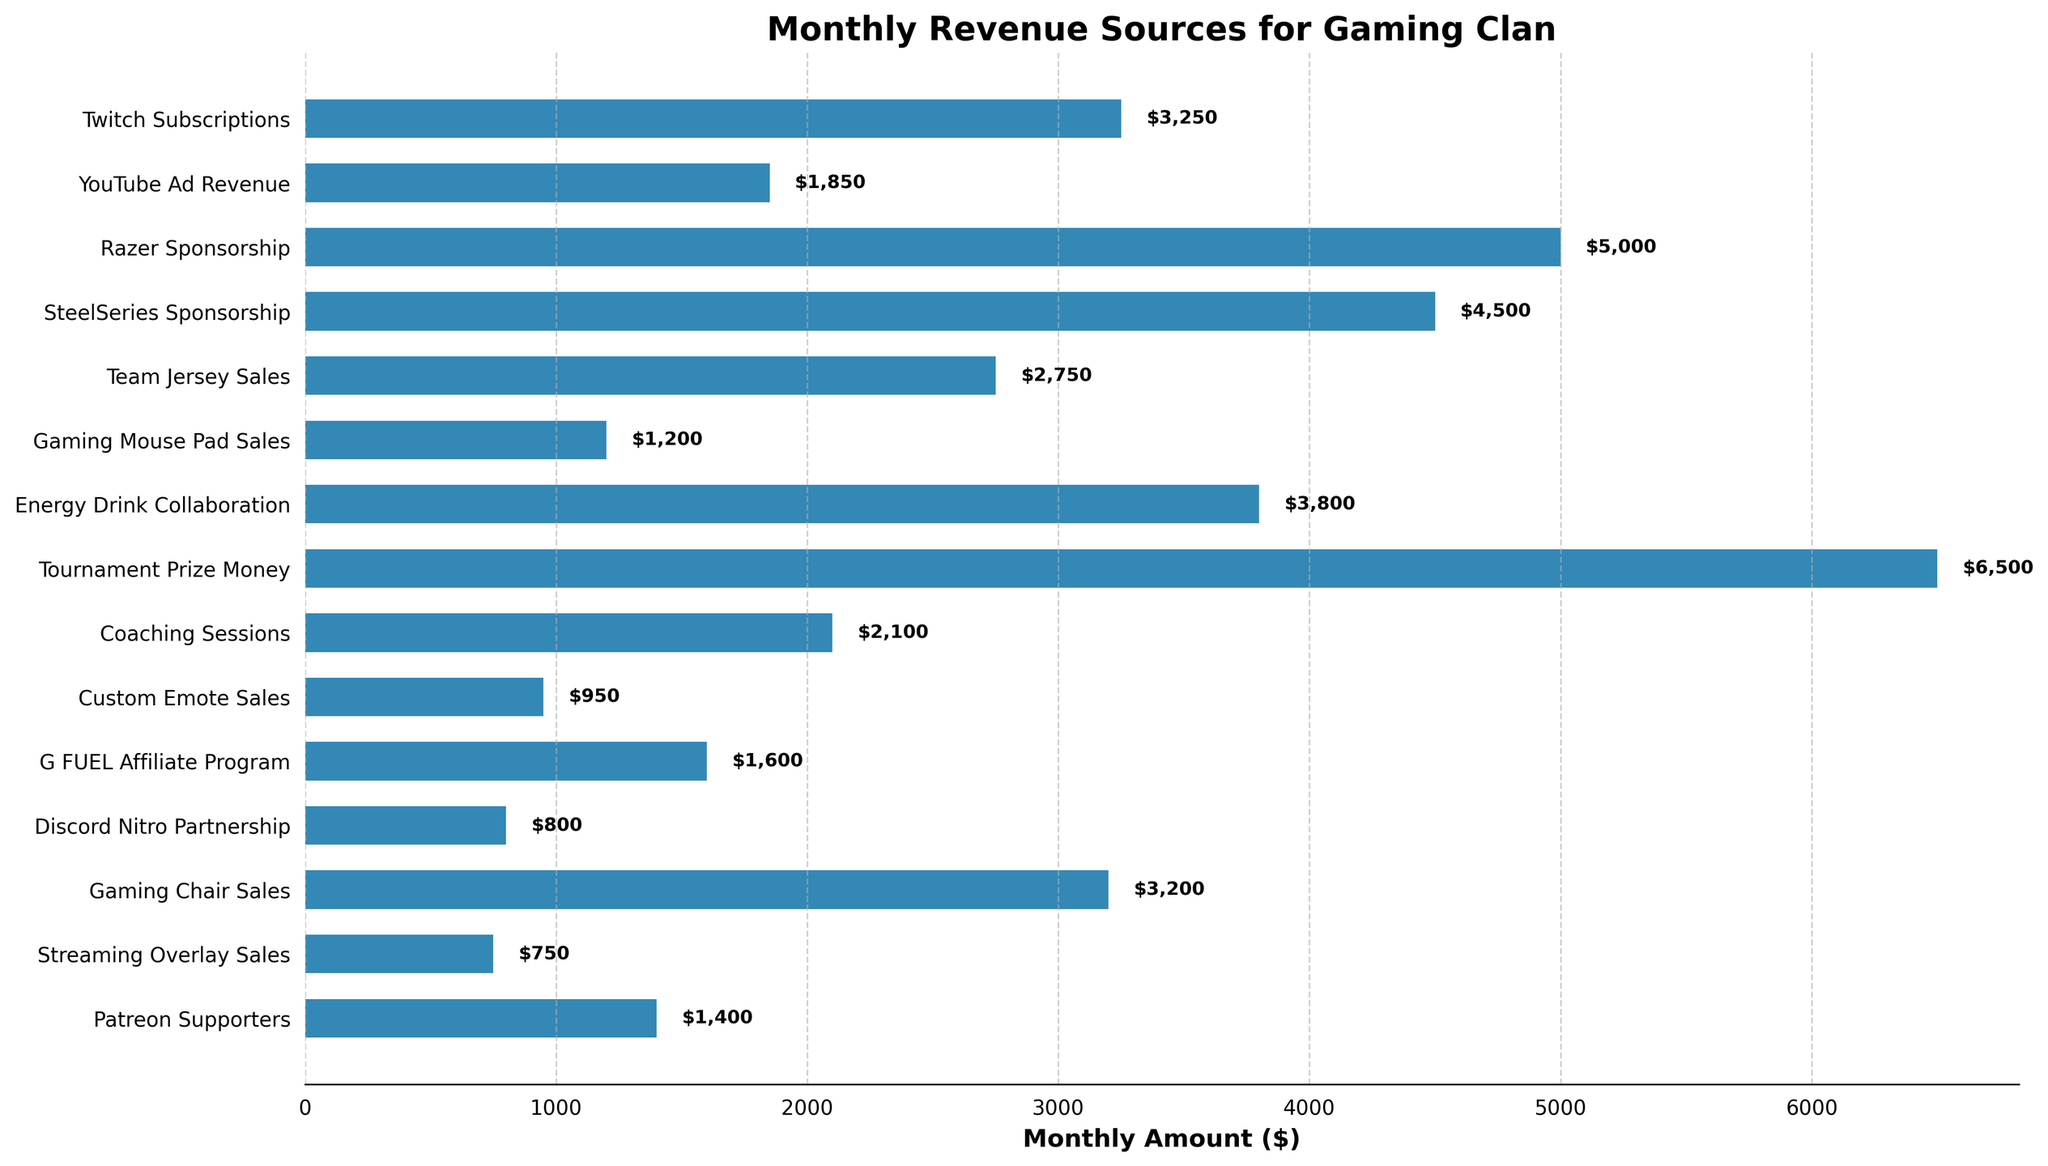What's the total monthly revenue from all sources combined? Sum all the monthly amounts listed: (3250 + 1850 + 5000 + 4500 + 2750 + 1200 + 3800 + 6500 + 2100 + 950 + 1600 + 800 + 3200 + 750 + 1400) = 42,650
Answer: 42,650 Which revenue source contributes the most monthly income? Identify the highest value bar in the plot, which has a label "Tournament Prize Money" and the amount is 6500
Answer: Tournament Prize Money Which is higher: the combined revenue from Twitch Subscriptions and YouTube Ad Revenue, or the Razer Sponsorship? Calculate the sum of Twitch Subscriptions and YouTube Ad Revenue (3250 + 1850 = 5100) and compare it with Razer Sponsorship (5000). 5100 is greater than 5000
Answer: Twitch Subscriptions and YouTube Ad Revenue What's the difference between the highest and the lowest monthly revenue sources? The highest monthly revenue source is Tournament Prize Money ($6500), and the lowest is Custom Emote Sales ($950). The difference is 6500 - 950 = 5550
Answer: 5550 Which sponsorship provides more revenue, Razer or SteelSeries? Compare the amounts for Razer Sponsorship ($5000) and SteelSeries Sponsorship ($4500). Razer is greater than SteelSeries
Answer: Razer Sponsorship What is the average monthly revenue from all sources? Calculate the total revenue (42650) and divide by the number of sources (15). 42650 / 15 = 2843.33
Answer: 2,843.33 How much more revenue does Tournament Prize Money generate compared to Energy Drink Collaboration? Subtract the Energy Drink Collaboration amount (3800) from Tournament Prize Money (6500). 6500 - 3800 = 2700
Answer: 2700 Which generates more revenue: Gaming Chair Sales or the combined revenue from Coaching Sessions and Custom Emote Sales? Compare Gaming Chair Sales ($3200) and the sum of Coaching Sessions and Custom Emote Sales (2100 + 950 = 3050). 3200 is greater than 3050
Answer: Gaming Chair Sales Which revenue sources are under $1000 in monthly revenue? Identify bars with values under $1000: "Custom Emote Sales" ($950)
Answer: Custom Emote Sales What is the second highest revenue source? The second highest bar after Tournament Prize Money ($6500) is Razer Sponsorship ($5000)
Answer: Razer Sponsorship 